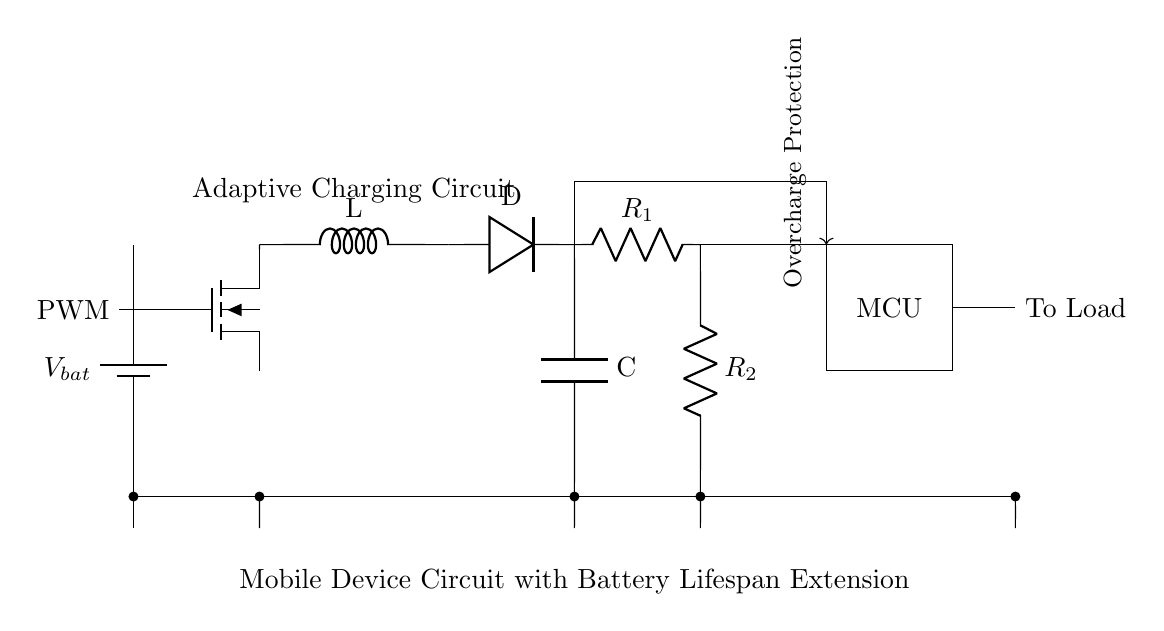What type of device is this circuit designed for? The circuit is designed for a mobile device, as indicated in the label at the bottom of the diagram.
Answer: mobile device What is the function of the MOSFET in this circuit? The MOSFET functions as a switch to control the charging process by responding to the PWM signal, allowing the circuit to adaptively manage the charging current.
Answer: switch How many resistors are present in the circuit? There are two resistors as labeled in the voltage divider section of the circuit.
Answer: two What component provides overcharge protection in the circuit? The overcharge protection is provided by the microcontroller, which monitors the charging process and regulates it as indicated by the label.
Answer: microcontroller What is the purpose of the inductor in the charging circuit? The inductor is used to store energy and smooth out the current flow during the charging process, helping to regulate the charging cycle for the battery.
Answer: store energy What are the labels for the resistors in the voltage divider? The resistors are labeled R1 and R2, which provide a division of voltage for monitoring the battery status.
Answer: R1 and R2 What does 'PWM' stand for and its role in this circuit? PWM stands for Pulse Width Modulation, and it is used to control the MOSFET for adjusting the charging current to the battery.
Answer: Pulse Width Modulation 